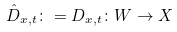Convert formula to latex. <formula><loc_0><loc_0><loc_500><loc_500>\hat { D } _ { x , t } \colon = D _ { x , t } \colon W \rightarrow X</formula> 